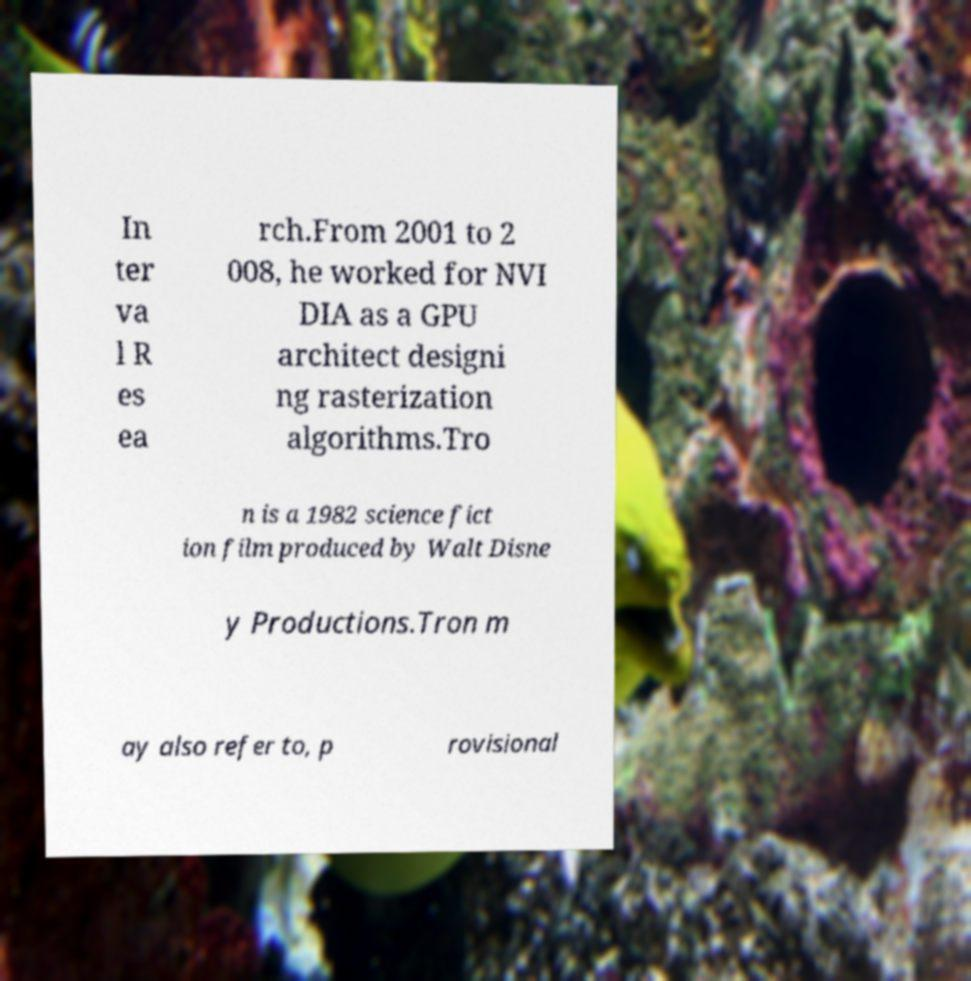Please read and relay the text visible in this image. What does it say? In ter va l R es ea rch.From 2001 to 2 008, he worked for NVI DIA as a GPU architect designi ng rasterization algorithms.Tro n is a 1982 science fict ion film produced by Walt Disne y Productions.Tron m ay also refer to, p rovisional 